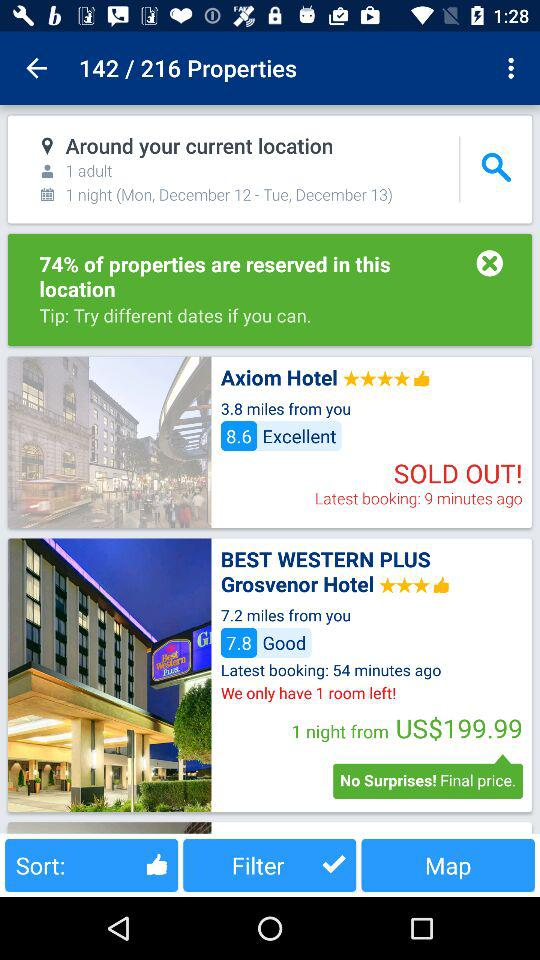How many total properties are there? There are a total of 216 properties. 